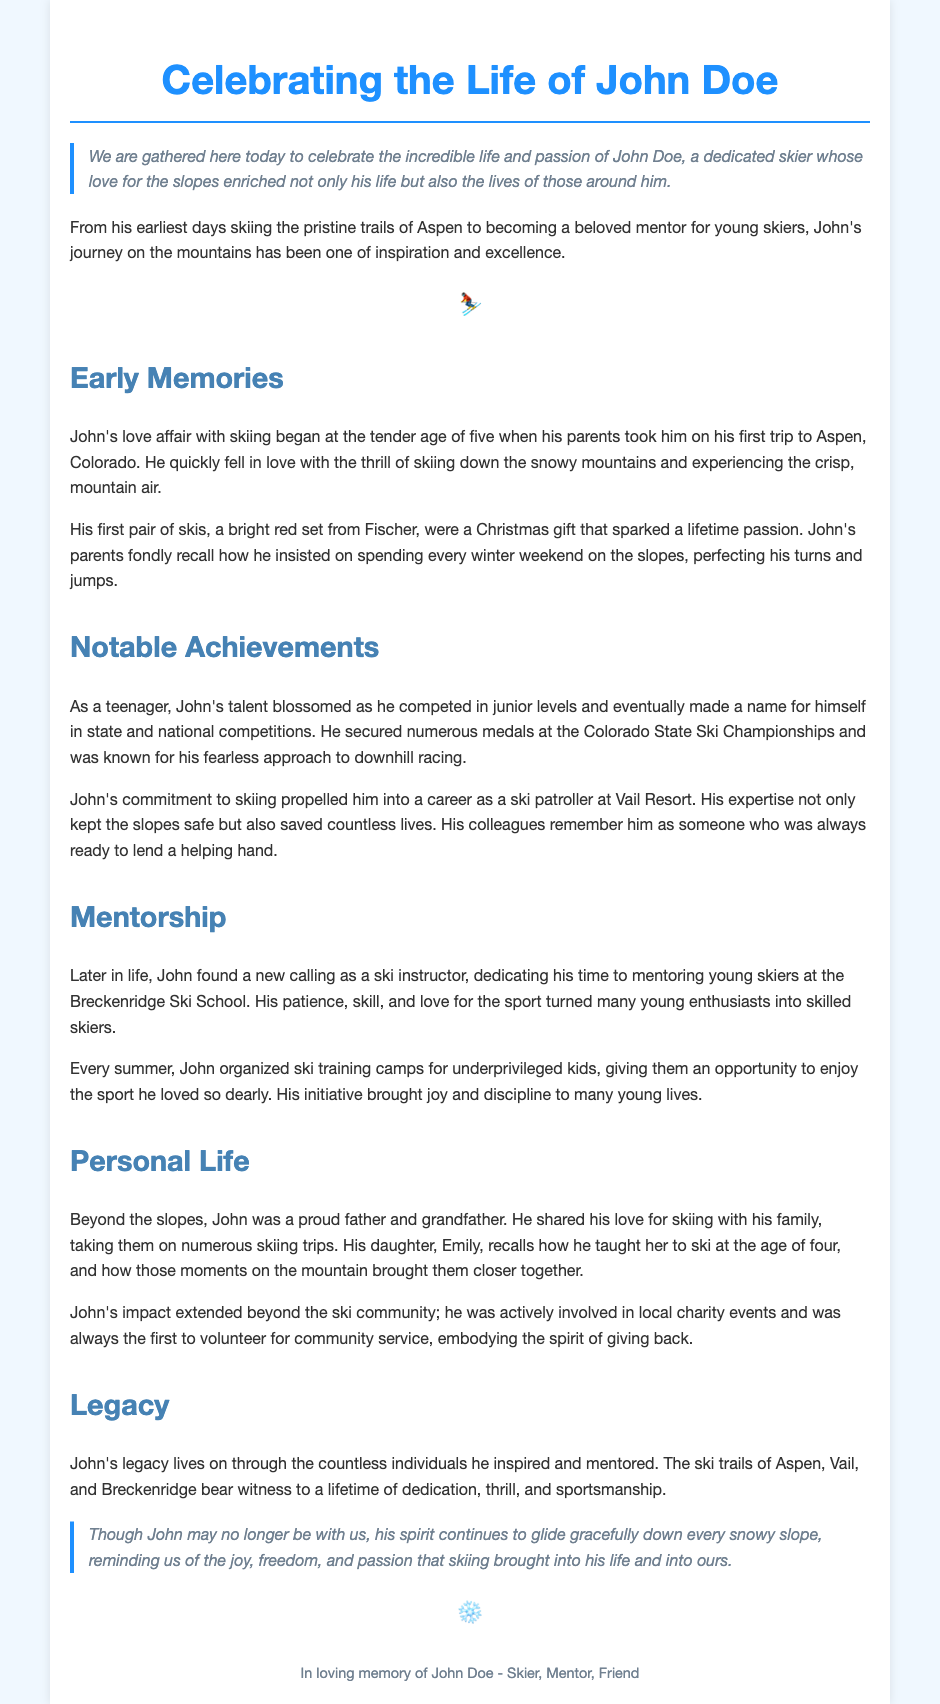What is the name of the person being celebrated? The eulogy is dedicated to John Doe, who is being celebrated for his life and skiing passions.
Answer: John Doe At what age did John begin skiing? The document states that John began skiing at the age of five when he went on his first trip to Aspen.
Answer: Five What was John's first pair of skis? The eulogy mentions that his first pair of skis were a bright red set from Fischer.
Answer: Bright red set from Fischer What role did John have at Vail Resort? The document indicates that John worked as a ski patroller, ensuring safety on the slopes.
Answer: Ski patroller Which ski school did John mentor young skiers at? The eulogy states that he mentored young skiers at the Breckenridge Ski School.
Answer: Breckenridge Ski School What initiative did John organize for underprivileged kids? John organized ski training camps in the summer to give underprivileged kids the opportunity to enjoy skiing.
Answer: Ski training camps Who is mentioned as John's daughter in the personal life section? The eulogy references his daughter, Emily, who learned to ski with him.
Answer: Emily What is the overall theme of the eulogy? The eulogy focuses on celebrating John's passion for skiing and the impact he had on others' lives.
Answer: Celebration of passion and impact 